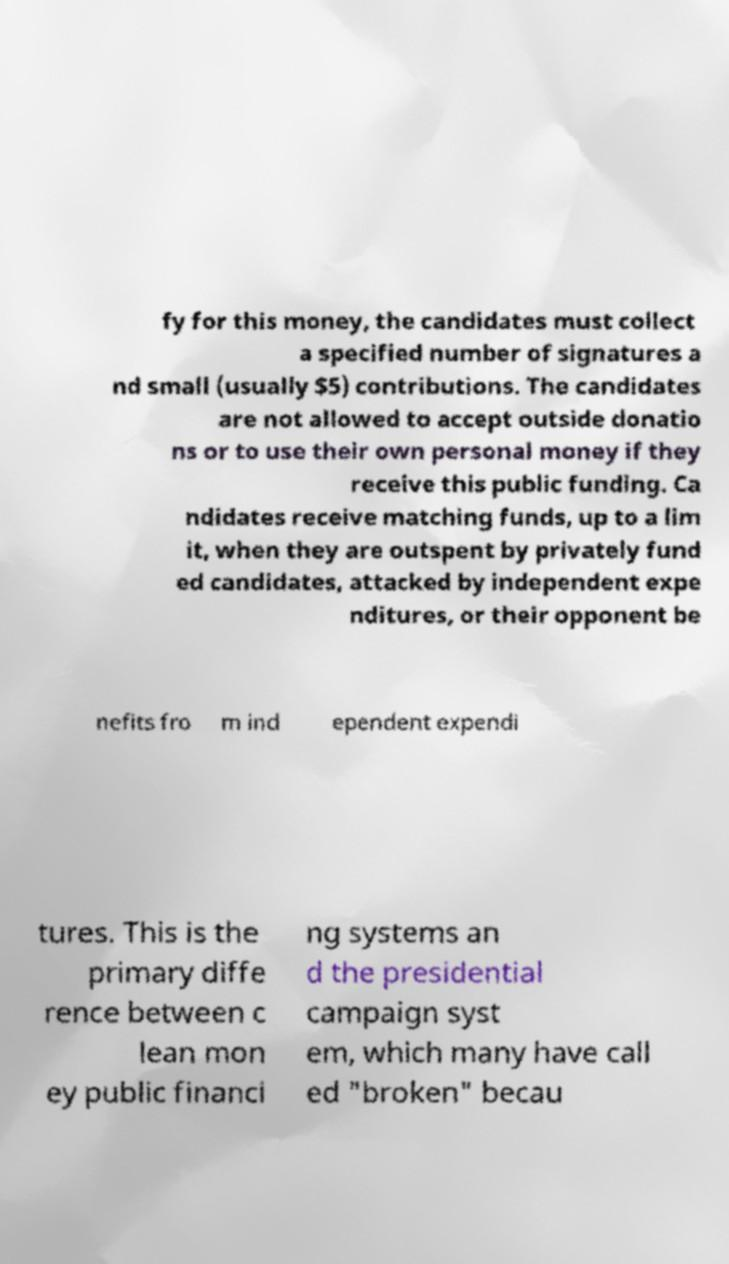Please identify and transcribe the text found in this image. fy for this money, the candidates must collect a specified number of signatures a nd small (usually $5) contributions. The candidates are not allowed to accept outside donatio ns or to use their own personal money if they receive this public funding. Ca ndidates receive matching funds, up to a lim it, when they are outspent by privately fund ed candidates, attacked by independent expe nditures, or their opponent be nefits fro m ind ependent expendi tures. This is the primary diffe rence between c lean mon ey public financi ng systems an d the presidential campaign syst em, which many have call ed "broken" becau 